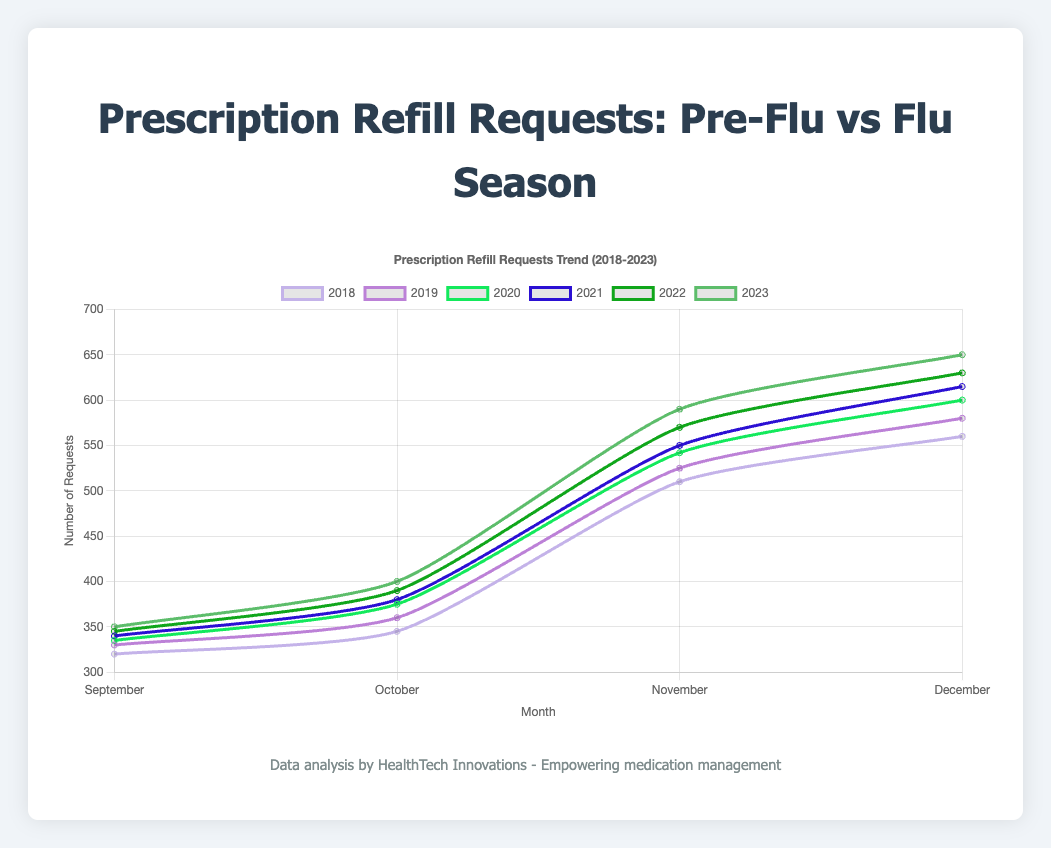Which month in 2023 saw the highest number of refill requests? By looking at the 2023 data line, you can observe that December shows the highest number of refill requests compared to other months in 2023.
Answer: December How does the number of refill requests in October 2021 compare to October 2023? From the lines representing 2021 and 2023, observe the points for October. October 2021 has 380 requests, while October 2023 has 400 requests.
Answer: October 2023 has 20 more requests than October 2021 What is the average number of refill requests in November across all given years? Calculate the average by summing the November requests across all years (510 + 525 + 542 + 550 + 570 + 590 = 3287) and then divide by the number of years (3287 / 6).
Answer: 548 Between September 2019 and September 2020, how did the refill requests change? By comparing the data points for September 2019 (330 requests) and September 2020 (335 requests), observe the difference.
Answer: Increased by 5 requests Which year shows the smallest increase in refill requests from October to November? Calculate the increase for each year (2018: 510-345=165, 2019: 525-360=165, 2020: 542-375=167, 2021: 550-380=170, 2022: 570-390=180, 2023: 590-400=190), 2018 and 2019 both show the smallest increase of 165 requests.
Answer: 2018 and 2019 How do the refill requests in December 2023 compare to December 2022? The December 2023 requests are 650, and the December 2022 requests are 630.
Answer: 20 more requests in 2023 Which pre-flu month over the years consistently had the lowest refill requests? Compare the data points for September and October over the years. September consistently has lower refill requests compared to October in all years.
Answer: September What is the difference in refill requests between the highest and lowest months in 2020? The lowest request month in 2020 is September (335 requests) and the highest is December (600 requests). The difference is 600 - 335.
Answer: 265 By how much did the refill requests in November 2021 exceed November 2018? Subtract the number of requests in November 2018 (510) from those in November 2021 (550).
Answer: 40 During which month and year did the highest overall number of refill requests occur? Looking at all the data points, December 2023 shows the highest number of refill requests (650 requests).
Answer: December 2023 